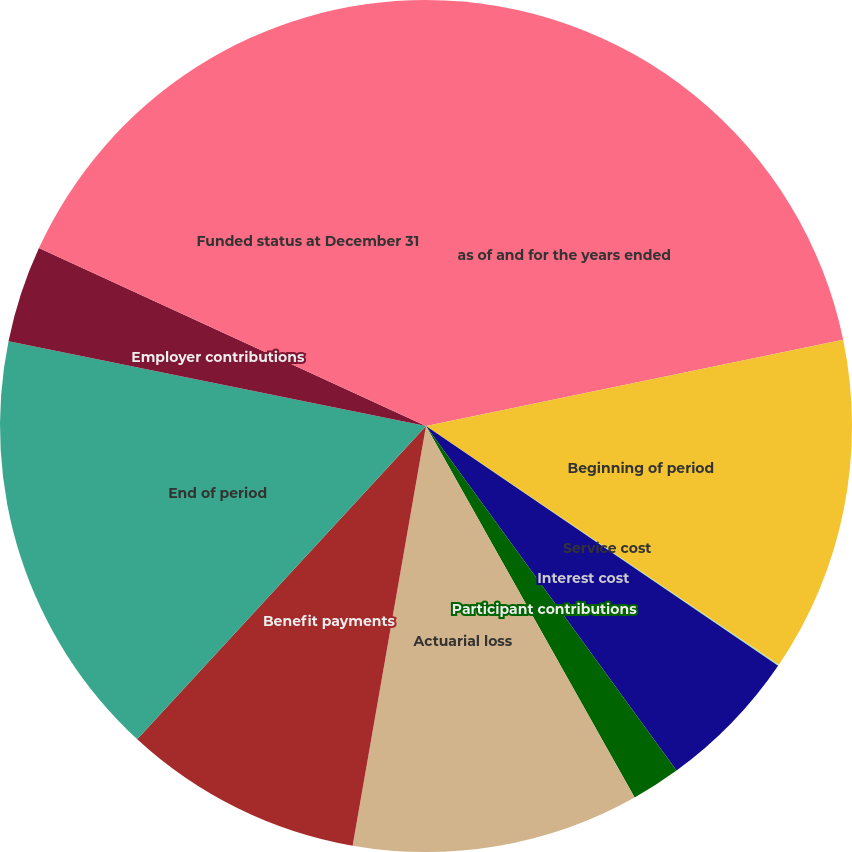Convert chart to OTSL. <chart><loc_0><loc_0><loc_500><loc_500><pie_chart><fcel>as of and for the years ended<fcel>Beginning of period<fcel>Service cost<fcel>Interest cost<fcel>Participant contributions<fcel>Actuarial loss<fcel>Benefit payments<fcel>End of period<fcel>Employer contributions<fcel>Funded status at December 31<nl><fcel>21.75%<fcel>12.71%<fcel>0.05%<fcel>5.48%<fcel>1.86%<fcel>10.9%<fcel>9.1%<fcel>16.33%<fcel>3.67%<fcel>18.14%<nl></chart> 